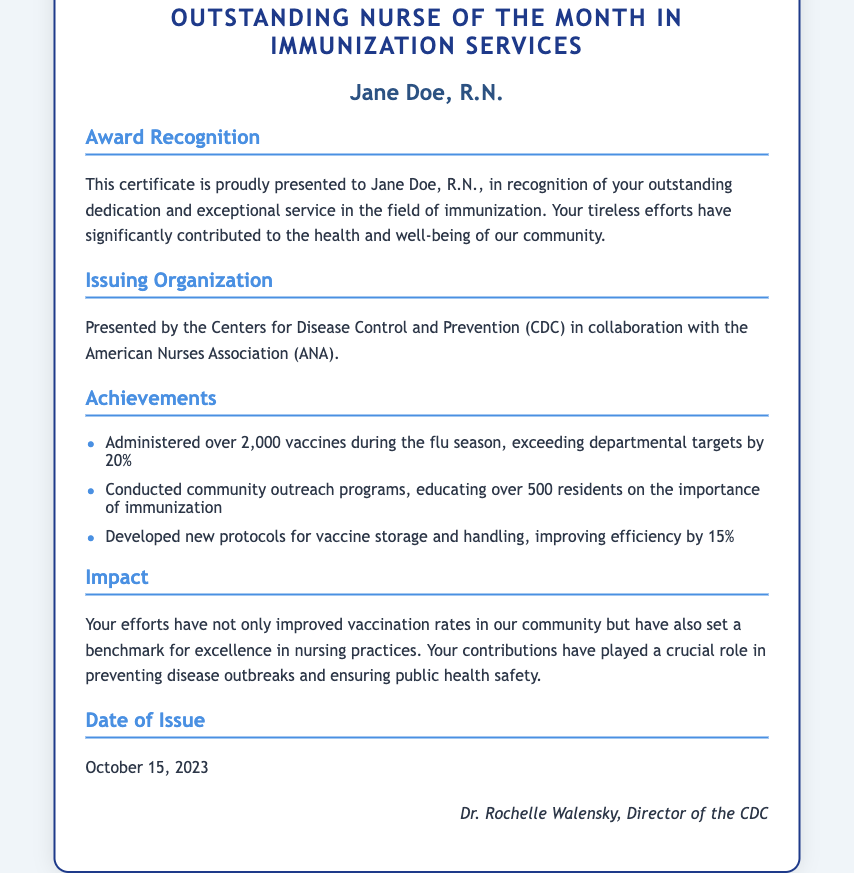What is the name of the certificate? The document is titled "Personal Achievement Certificate for Outstanding Nurse of the Month in Immunization Services."
Answer: Personal Achievement Certificate for Outstanding Nurse of the Month in Immunization Services Who is the recipient of the certificate? The recipient's name is presented in the document.
Answer: Jane Doe, R.N What organization issued the certificate? The issuing organization is specified in the document.
Answer: Centers for Disease Control and Prevention (CDC) How many vaccines did Jane Doe administer during the flu season? The document states that she administered a specific number of vaccines during the flu season.
Answer: over 2,000 vaccines What is the date of issue for the certificate? The certificate includes the date it was issued.
Answer: October 15, 2023 Who is the presenter of the certificate? The presenter is named at the bottom of the document.
Answer: Dr. Rochelle Walensky, Director of the CDC What improvement percentage did Jane Doe achieve in efficiency for vaccine storage? The document mentions a specific percentage improvement for vaccine storage efficiency.
Answer: 15% What was one of Jane Doe's community contributions? The document lists her efforts in community outreach as a specific contribution.
Answer: Educating over 500 residents on the importance of immunization What theme is emphasized in the impact section? The impact section describes the overall result of her contributions.
Answer: Improved vaccination rates in our community 